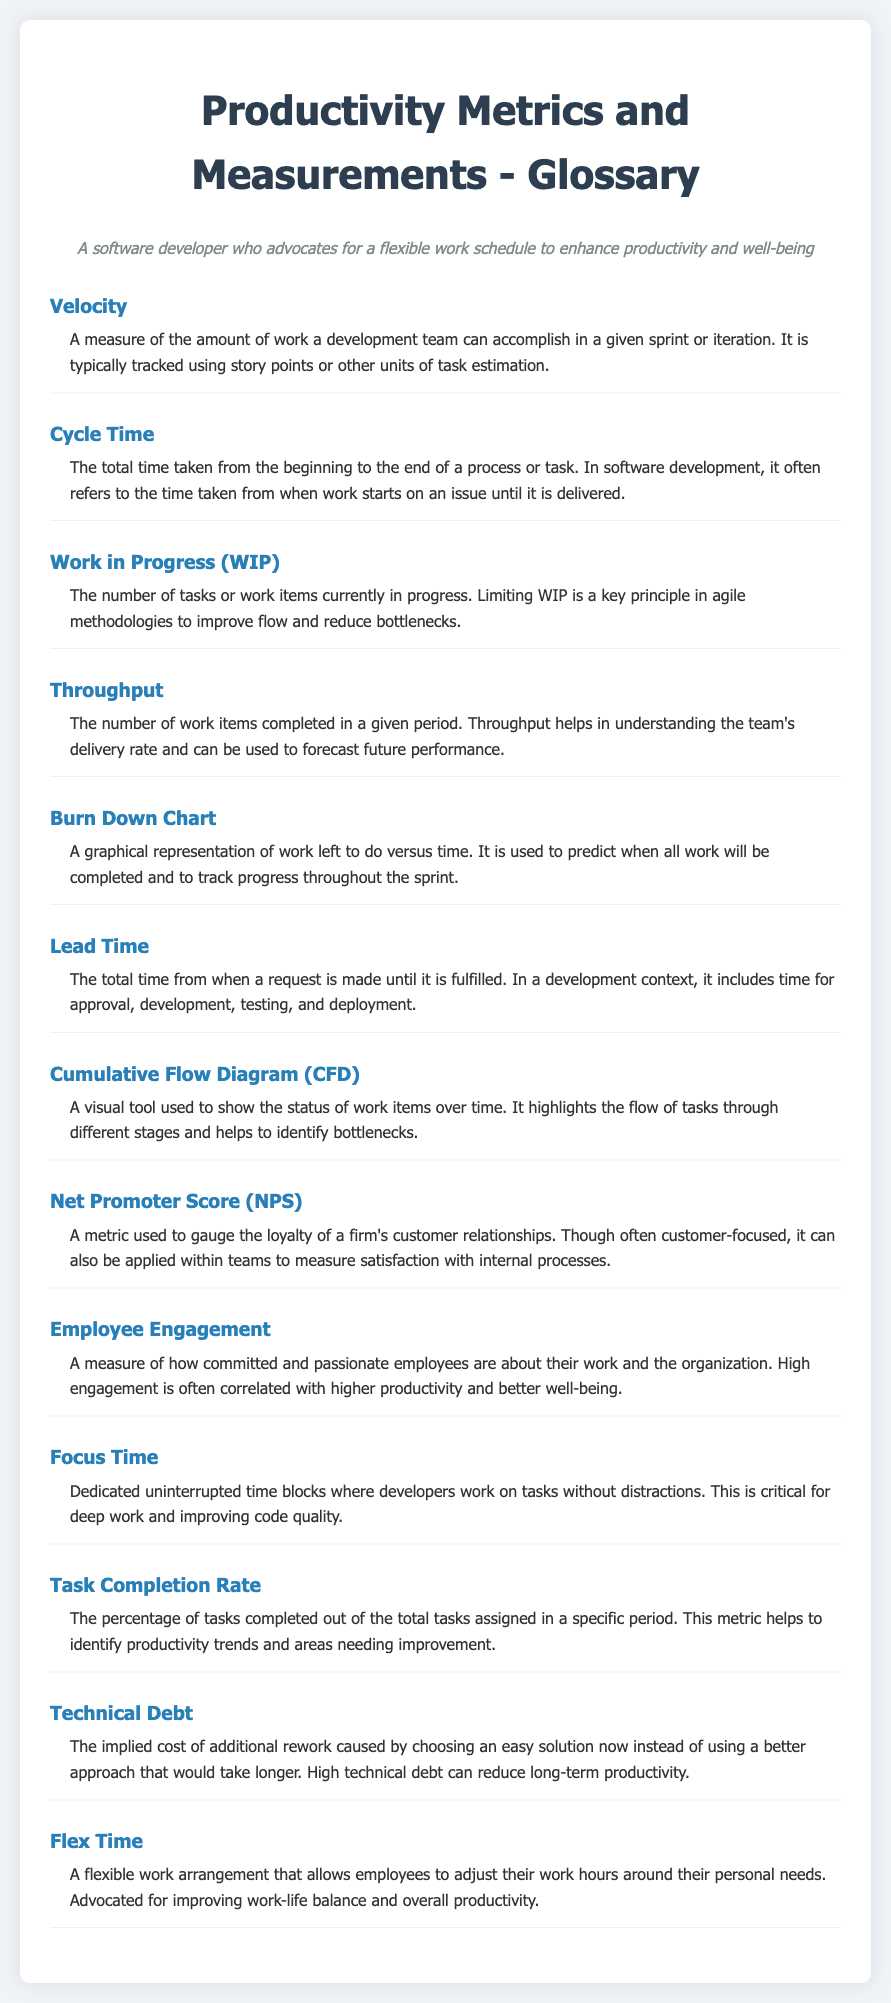what is the term for the amount of work a team can accomplish in a sprint? The term defined in the document is "Velocity," which measures the amount of work a development team can accomplish in a given sprint or iteration.
Answer: Velocity what does WIP stand for? WIP is defined in the document as "Work in Progress," which refers to the number of tasks or work items currently in progress.
Answer: Work in Progress what is a Burn Down Chart used for? The document states that a Burn Down Chart is used to track progress throughout the sprint and predict when all work will be completed.
Answer: To predict completion of work how does Flex Time benefit employees? According to the document, Flex Time benefits employees by allowing them to adjust their work hours around their personal needs, improving work-life balance and overall productivity.
Answer: Work-life balance what metric measures customer loyalty? The document mentions the Net Promoter Score (NPS) as a metric used to gauge the loyalty of a firm's customer relationships.
Answer: Net Promoter Score what is the percentage of tasks completed out of the total tasks assigned called? The document explains that this measure is called the Task Completion Rate, which shows the percentage of tasks completed out of total tasks assigned.
Answer: Task Completion Rate what is one consequence of high technical debt? The document states that high technical debt can reduce long-term productivity in software development.
Answer: Reduced productivity what does Cycle Time refer to? The document defines Cycle Time as the total time taken from the beginning to the end of a process or task.
Answer: Total time from start to finish how can limiting WIP help an agile team? Limiting WIP helps improve flow and reduce bottlenecks, according to the document's definition of Work in Progress.
Answer: Improve flow and reduce bottlenecks 